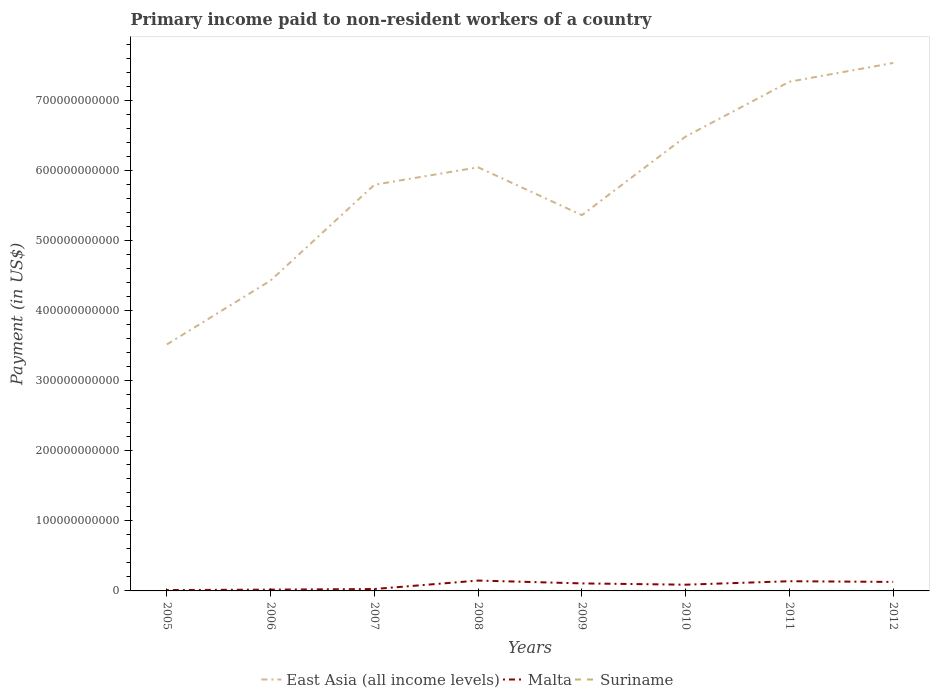How many different coloured lines are there?
Your answer should be very brief. 3. Does the line corresponding to Malta intersect with the line corresponding to East Asia (all income levels)?
Provide a succinct answer. No. Across all years, what is the maximum amount paid to workers in Malta?
Your answer should be very brief. 1.21e+09. In which year was the amount paid to workers in Suriname maximum?
Make the answer very short. 2011. What is the total amount paid to workers in Malta in the graph?
Provide a short and direct response. -1.20e+1. What is the difference between the highest and the second highest amount paid to workers in Malta?
Provide a short and direct response. 1.36e+1. What is the difference between the highest and the lowest amount paid to workers in Malta?
Ensure brevity in your answer.  5. How many years are there in the graph?
Offer a terse response. 8. What is the difference between two consecutive major ticks on the Y-axis?
Your response must be concise. 1.00e+11. Does the graph contain grids?
Ensure brevity in your answer.  No. What is the title of the graph?
Keep it short and to the point. Primary income paid to non-resident workers of a country. Does "Mali" appear as one of the legend labels in the graph?
Give a very brief answer. No. What is the label or title of the Y-axis?
Make the answer very short. Payment (in US$). What is the Payment (in US$) of East Asia (all income levels) in 2005?
Make the answer very short. 3.52e+11. What is the Payment (in US$) in Malta in 2005?
Provide a short and direct response. 1.21e+09. What is the Payment (in US$) of Suriname in 2005?
Your answer should be very brief. 2.40e+07. What is the Payment (in US$) of East Asia (all income levels) in 2006?
Offer a very short reply. 4.43e+11. What is the Payment (in US$) of Malta in 2006?
Your answer should be very brief. 1.84e+09. What is the Payment (in US$) in Suriname in 2006?
Give a very brief answer. 2.50e+07. What is the Payment (in US$) in East Asia (all income levels) in 2007?
Ensure brevity in your answer.  5.80e+11. What is the Payment (in US$) in Malta in 2007?
Your response must be concise. 2.71e+09. What is the Payment (in US$) in Suriname in 2007?
Ensure brevity in your answer.  4.36e+07. What is the Payment (in US$) in East Asia (all income levels) in 2008?
Offer a very short reply. 6.05e+11. What is the Payment (in US$) of Malta in 2008?
Give a very brief answer. 1.48e+1. What is the Payment (in US$) of Suriname in 2008?
Offer a very short reply. 4.22e+07. What is the Payment (in US$) in East Asia (all income levels) in 2009?
Your answer should be very brief. 5.36e+11. What is the Payment (in US$) of Malta in 2009?
Your answer should be compact. 1.07e+1. What is the Payment (in US$) of Suriname in 2009?
Make the answer very short. 2.98e+07. What is the Payment (in US$) of East Asia (all income levels) in 2010?
Ensure brevity in your answer.  6.48e+11. What is the Payment (in US$) of Malta in 2010?
Offer a very short reply. 8.90e+09. What is the Payment (in US$) in Suriname in 2010?
Keep it short and to the point. 2.61e+07. What is the Payment (in US$) of East Asia (all income levels) in 2011?
Provide a short and direct response. 7.27e+11. What is the Payment (in US$) in Malta in 2011?
Your answer should be compact. 1.38e+1. What is the Payment (in US$) in Suriname in 2011?
Keep it short and to the point. 1.62e+07. What is the Payment (in US$) in East Asia (all income levels) in 2012?
Provide a short and direct response. 7.53e+11. What is the Payment (in US$) in Malta in 2012?
Offer a very short reply. 1.29e+1. What is the Payment (in US$) in Suriname in 2012?
Your answer should be very brief. 2.71e+07. Across all years, what is the maximum Payment (in US$) of East Asia (all income levels)?
Offer a very short reply. 7.53e+11. Across all years, what is the maximum Payment (in US$) in Malta?
Offer a terse response. 1.48e+1. Across all years, what is the maximum Payment (in US$) in Suriname?
Your response must be concise. 4.36e+07. Across all years, what is the minimum Payment (in US$) of East Asia (all income levels)?
Make the answer very short. 3.52e+11. Across all years, what is the minimum Payment (in US$) in Malta?
Offer a very short reply. 1.21e+09. Across all years, what is the minimum Payment (in US$) in Suriname?
Keep it short and to the point. 1.62e+07. What is the total Payment (in US$) of East Asia (all income levels) in the graph?
Make the answer very short. 4.64e+12. What is the total Payment (in US$) in Malta in the graph?
Give a very brief answer. 6.69e+1. What is the total Payment (in US$) in Suriname in the graph?
Your answer should be compact. 2.34e+08. What is the difference between the Payment (in US$) of East Asia (all income levels) in 2005 and that in 2006?
Give a very brief answer. -9.13e+1. What is the difference between the Payment (in US$) in Malta in 2005 and that in 2006?
Your response must be concise. -6.32e+08. What is the difference between the Payment (in US$) in East Asia (all income levels) in 2005 and that in 2007?
Give a very brief answer. -2.28e+11. What is the difference between the Payment (in US$) in Malta in 2005 and that in 2007?
Keep it short and to the point. -1.50e+09. What is the difference between the Payment (in US$) in Suriname in 2005 and that in 2007?
Provide a short and direct response. -1.96e+07. What is the difference between the Payment (in US$) of East Asia (all income levels) in 2005 and that in 2008?
Provide a short and direct response. -2.53e+11. What is the difference between the Payment (in US$) in Malta in 2005 and that in 2008?
Your answer should be compact. -1.36e+1. What is the difference between the Payment (in US$) in Suriname in 2005 and that in 2008?
Offer a terse response. -1.82e+07. What is the difference between the Payment (in US$) in East Asia (all income levels) in 2005 and that in 2009?
Your answer should be very brief. -1.85e+11. What is the difference between the Payment (in US$) in Malta in 2005 and that in 2009?
Keep it short and to the point. -9.52e+09. What is the difference between the Payment (in US$) of Suriname in 2005 and that in 2009?
Provide a succinct answer. -5.80e+06. What is the difference between the Payment (in US$) of East Asia (all income levels) in 2005 and that in 2010?
Your response must be concise. -2.97e+11. What is the difference between the Payment (in US$) of Malta in 2005 and that in 2010?
Give a very brief answer. -7.69e+09. What is the difference between the Payment (in US$) in Suriname in 2005 and that in 2010?
Make the answer very short. -2.10e+06. What is the difference between the Payment (in US$) of East Asia (all income levels) in 2005 and that in 2011?
Your answer should be very brief. -3.75e+11. What is the difference between the Payment (in US$) of Malta in 2005 and that in 2011?
Ensure brevity in your answer.  -1.26e+1. What is the difference between the Payment (in US$) of Suriname in 2005 and that in 2011?
Make the answer very short. 7.83e+06. What is the difference between the Payment (in US$) of East Asia (all income levels) in 2005 and that in 2012?
Make the answer very short. -4.02e+11. What is the difference between the Payment (in US$) of Malta in 2005 and that in 2012?
Offer a terse response. -1.17e+1. What is the difference between the Payment (in US$) of Suriname in 2005 and that in 2012?
Provide a short and direct response. -3.10e+06. What is the difference between the Payment (in US$) of East Asia (all income levels) in 2006 and that in 2007?
Provide a succinct answer. -1.37e+11. What is the difference between the Payment (in US$) of Malta in 2006 and that in 2007?
Give a very brief answer. -8.71e+08. What is the difference between the Payment (in US$) of Suriname in 2006 and that in 2007?
Your answer should be compact. -1.86e+07. What is the difference between the Payment (in US$) in East Asia (all income levels) in 2006 and that in 2008?
Offer a very short reply. -1.62e+11. What is the difference between the Payment (in US$) of Malta in 2006 and that in 2008?
Offer a terse response. -1.30e+1. What is the difference between the Payment (in US$) in Suriname in 2006 and that in 2008?
Your response must be concise. -1.72e+07. What is the difference between the Payment (in US$) of East Asia (all income levels) in 2006 and that in 2009?
Your answer should be very brief. -9.33e+1. What is the difference between the Payment (in US$) in Malta in 2006 and that in 2009?
Your answer should be compact. -8.89e+09. What is the difference between the Payment (in US$) in Suriname in 2006 and that in 2009?
Ensure brevity in your answer.  -4.80e+06. What is the difference between the Payment (in US$) of East Asia (all income levels) in 2006 and that in 2010?
Offer a very short reply. -2.05e+11. What is the difference between the Payment (in US$) in Malta in 2006 and that in 2010?
Provide a succinct answer. -7.06e+09. What is the difference between the Payment (in US$) of Suriname in 2006 and that in 2010?
Offer a very short reply. -1.10e+06. What is the difference between the Payment (in US$) of East Asia (all income levels) in 2006 and that in 2011?
Provide a succinct answer. -2.84e+11. What is the difference between the Payment (in US$) of Malta in 2006 and that in 2011?
Your answer should be very brief. -1.20e+1. What is the difference between the Payment (in US$) in Suriname in 2006 and that in 2011?
Your response must be concise. 8.83e+06. What is the difference between the Payment (in US$) in East Asia (all income levels) in 2006 and that in 2012?
Provide a short and direct response. -3.10e+11. What is the difference between the Payment (in US$) of Malta in 2006 and that in 2012?
Make the answer very short. -1.10e+1. What is the difference between the Payment (in US$) in Suriname in 2006 and that in 2012?
Offer a very short reply. -2.10e+06. What is the difference between the Payment (in US$) in East Asia (all income levels) in 2007 and that in 2008?
Keep it short and to the point. -2.49e+1. What is the difference between the Payment (in US$) of Malta in 2007 and that in 2008?
Your answer should be very brief. -1.21e+1. What is the difference between the Payment (in US$) of Suriname in 2007 and that in 2008?
Your response must be concise. 1.40e+06. What is the difference between the Payment (in US$) of East Asia (all income levels) in 2007 and that in 2009?
Give a very brief answer. 4.34e+1. What is the difference between the Payment (in US$) of Malta in 2007 and that in 2009?
Make the answer very short. -8.02e+09. What is the difference between the Payment (in US$) in Suriname in 2007 and that in 2009?
Make the answer very short. 1.38e+07. What is the difference between the Payment (in US$) in East Asia (all income levels) in 2007 and that in 2010?
Give a very brief answer. -6.88e+1. What is the difference between the Payment (in US$) of Malta in 2007 and that in 2010?
Offer a very short reply. -6.18e+09. What is the difference between the Payment (in US$) of Suriname in 2007 and that in 2010?
Keep it short and to the point. 1.75e+07. What is the difference between the Payment (in US$) in East Asia (all income levels) in 2007 and that in 2011?
Offer a terse response. -1.47e+11. What is the difference between the Payment (in US$) in Malta in 2007 and that in 2011?
Your response must be concise. -1.11e+1. What is the difference between the Payment (in US$) of Suriname in 2007 and that in 2011?
Keep it short and to the point. 2.74e+07. What is the difference between the Payment (in US$) of East Asia (all income levels) in 2007 and that in 2012?
Your answer should be very brief. -1.74e+11. What is the difference between the Payment (in US$) in Malta in 2007 and that in 2012?
Provide a succinct answer. -1.01e+1. What is the difference between the Payment (in US$) in Suriname in 2007 and that in 2012?
Make the answer very short. 1.65e+07. What is the difference between the Payment (in US$) of East Asia (all income levels) in 2008 and that in 2009?
Keep it short and to the point. 6.83e+1. What is the difference between the Payment (in US$) of Malta in 2008 and that in 2009?
Make the answer very short. 4.06e+09. What is the difference between the Payment (in US$) of Suriname in 2008 and that in 2009?
Provide a short and direct response. 1.24e+07. What is the difference between the Payment (in US$) in East Asia (all income levels) in 2008 and that in 2010?
Offer a terse response. -4.39e+1. What is the difference between the Payment (in US$) in Malta in 2008 and that in 2010?
Give a very brief answer. 5.90e+09. What is the difference between the Payment (in US$) in Suriname in 2008 and that in 2010?
Keep it short and to the point. 1.61e+07. What is the difference between the Payment (in US$) of East Asia (all income levels) in 2008 and that in 2011?
Offer a terse response. -1.22e+11. What is the difference between the Payment (in US$) of Malta in 2008 and that in 2011?
Keep it short and to the point. 9.48e+08. What is the difference between the Payment (in US$) in Suriname in 2008 and that in 2011?
Provide a succinct answer. 2.60e+07. What is the difference between the Payment (in US$) of East Asia (all income levels) in 2008 and that in 2012?
Your answer should be very brief. -1.49e+11. What is the difference between the Payment (in US$) in Malta in 2008 and that in 2012?
Your response must be concise. 1.93e+09. What is the difference between the Payment (in US$) in Suriname in 2008 and that in 2012?
Provide a short and direct response. 1.51e+07. What is the difference between the Payment (in US$) in East Asia (all income levels) in 2009 and that in 2010?
Your answer should be compact. -1.12e+11. What is the difference between the Payment (in US$) in Malta in 2009 and that in 2010?
Offer a terse response. 1.84e+09. What is the difference between the Payment (in US$) in Suriname in 2009 and that in 2010?
Give a very brief answer. 3.70e+06. What is the difference between the Payment (in US$) of East Asia (all income levels) in 2009 and that in 2011?
Offer a terse response. -1.90e+11. What is the difference between the Payment (in US$) in Malta in 2009 and that in 2011?
Ensure brevity in your answer.  -3.11e+09. What is the difference between the Payment (in US$) in Suriname in 2009 and that in 2011?
Your response must be concise. 1.36e+07. What is the difference between the Payment (in US$) in East Asia (all income levels) in 2009 and that in 2012?
Give a very brief answer. -2.17e+11. What is the difference between the Payment (in US$) in Malta in 2009 and that in 2012?
Your answer should be compact. -2.13e+09. What is the difference between the Payment (in US$) of Suriname in 2009 and that in 2012?
Provide a succinct answer. 2.70e+06. What is the difference between the Payment (in US$) of East Asia (all income levels) in 2010 and that in 2011?
Ensure brevity in your answer.  -7.82e+1. What is the difference between the Payment (in US$) in Malta in 2010 and that in 2011?
Your answer should be compact. -4.95e+09. What is the difference between the Payment (in US$) in Suriname in 2010 and that in 2011?
Your answer should be compact. 9.93e+06. What is the difference between the Payment (in US$) of East Asia (all income levels) in 2010 and that in 2012?
Your answer should be very brief. -1.05e+11. What is the difference between the Payment (in US$) in Malta in 2010 and that in 2012?
Ensure brevity in your answer.  -3.97e+09. What is the difference between the Payment (in US$) of Suriname in 2010 and that in 2012?
Provide a short and direct response. -1.00e+06. What is the difference between the Payment (in US$) in East Asia (all income levels) in 2011 and that in 2012?
Your answer should be very brief. -2.68e+1. What is the difference between the Payment (in US$) in Malta in 2011 and that in 2012?
Give a very brief answer. 9.84e+08. What is the difference between the Payment (in US$) in Suriname in 2011 and that in 2012?
Provide a short and direct response. -1.09e+07. What is the difference between the Payment (in US$) in East Asia (all income levels) in 2005 and the Payment (in US$) in Malta in 2006?
Provide a short and direct response. 3.50e+11. What is the difference between the Payment (in US$) of East Asia (all income levels) in 2005 and the Payment (in US$) of Suriname in 2006?
Your response must be concise. 3.52e+11. What is the difference between the Payment (in US$) in Malta in 2005 and the Payment (in US$) in Suriname in 2006?
Provide a short and direct response. 1.18e+09. What is the difference between the Payment (in US$) in East Asia (all income levels) in 2005 and the Payment (in US$) in Malta in 2007?
Your response must be concise. 3.49e+11. What is the difference between the Payment (in US$) of East Asia (all income levels) in 2005 and the Payment (in US$) of Suriname in 2007?
Make the answer very short. 3.52e+11. What is the difference between the Payment (in US$) in Malta in 2005 and the Payment (in US$) in Suriname in 2007?
Keep it short and to the point. 1.16e+09. What is the difference between the Payment (in US$) of East Asia (all income levels) in 2005 and the Payment (in US$) of Malta in 2008?
Offer a terse response. 3.37e+11. What is the difference between the Payment (in US$) in East Asia (all income levels) in 2005 and the Payment (in US$) in Suriname in 2008?
Give a very brief answer. 3.52e+11. What is the difference between the Payment (in US$) of Malta in 2005 and the Payment (in US$) of Suriname in 2008?
Your response must be concise. 1.17e+09. What is the difference between the Payment (in US$) of East Asia (all income levels) in 2005 and the Payment (in US$) of Malta in 2009?
Your answer should be very brief. 3.41e+11. What is the difference between the Payment (in US$) of East Asia (all income levels) in 2005 and the Payment (in US$) of Suriname in 2009?
Offer a terse response. 3.52e+11. What is the difference between the Payment (in US$) of Malta in 2005 and the Payment (in US$) of Suriname in 2009?
Your answer should be compact. 1.18e+09. What is the difference between the Payment (in US$) of East Asia (all income levels) in 2005 and the Payment (in US$) of Malta in 2010?
Your answer should be compact. 3.43e+11. What is the difference between the Payment (in US$) of East Asia (all income levels) in 2005 and the Payment (in US$) of Suriname in 2010?
Offer a terse response. 3.52e+11. What is the difference between the Payment (in US$) in Malta in 2005 and the Payment (in US$) in Suriname in 2010?
Provide a succinct answer. 1.18e+09. What is the difference between the Payment (in US$) in East Asia (all income levels) in 2005 and the Payment (in US$) in Malta in 2011?
Provide a succinct answer. 3.38e+11. What is the difference between the Payment (in US$) in East Asia (all income levels) in 2005 and the Payment (in US$) in Suriname in 2011?
Your answer should be compact. 3.52e+11. What is the difference between the Payment (in US$) of Malta in 2005 and the Payment (in US$) of Suriname in 2011?
Keep it short and to the point. 1.19e+09. What is the difference between the Payment (in US$) of East Asia (all income levels) in 2005 and the Payment (in US$) of Malta in 2012?
Give a very brief answer. 3.39e+11. What is the difference between the Payment (in US$) of East Asia (all income levels) in 2005 and the Payment (in US$) of Suriname in 2012?
Your answer should be compact. 3.52e+11. What is the difference between the Payment (in US$) in Malta in 2005 and the Payment (in US$) in Suriname in 2012?
Your answer should be very brief. 1.18e+09. What is the difference between the Payment (in US$) of East Asia (all income levels) in 2006 and the Payment (in US$) of Malta in 2007?
Make the answer very short. 4.40e+11. What is the difference between the Payment (in US$) of East Asia (all income levels) in 2006 and the Payment (in US$) of Suriname in 2007?
Offer a terse response. 4.43e+11. What is the difference between the Payment (in US$) in Malta in 2006 and the Payment (in US$) in Suriname in 2007?
Offer a very short reply. 1.80e+09. What is the difference between the Payment (in US$) in East Asia (all income levels) in 2006 and the Payment (in US$) in Malta in 2008?
Give a very brief answer. 4.28e+11. What is the difference between the Payment (in US$) in East Asia (all income levels) in 2006 and the Payment (in US$) in Suriname in 2008?
Provide a succinct answer. 4.43e+11. What is the difference between the Payment (in US$) in Malta in 2006 and the Payment (in US$) in Suriname in 2008?
Provide a short and direct response. 1.80e+09. What is the difference between the Payment (in US$) of East Asia (all income levels) in 2006 and the Payment (in US$) of Malta in 2009?
Offer a terse response. 4.32e+11. What is the difference between the Payment (in US$) of East Asia (all income levels) in 2006 and the Payment (in US$) of Suriname in 2009?
Provide a short and direct response. 4.43e+11. What is the difference between the Payment (in US$) in Malta in 2006 and the Payment (in US$) in Suriname in 2009?
Give a very brief answer. 1.81e+09. What is the difference between the Payment (in US$) in East Asia (all income levels) in 2006 and the Payment (in US$) in Malta in 2010?
Ensure brevity in your answer.  4.34e+11. What is the difference between the Payment (in US$) of East Asia (all income levels) in 2006 and the Payment (in US$) of Suriname in 2010?
Your answer should be very brief. 4.43e+11. What is the difference between the Payment (in US$) in Malta in 2006 and the Payment (in US$) in Suriname in 2010?
Ensure brevity in your answer.  1.81e+09. What is the difference between the Payment (in US$) in East Asia (all income levels) in 2006 and the Payment (in US$) in Malta in 2011?
Ensure brevity in your answer.  4.29e+11. What is the difference between the Payment (in US$) of East Asia (all income levels) in 2006 and the Payment (in US$) of Suriname in 2011?
Your answer should be very brief. 4.43e+11. What is the difference between the Payment (in US$) of Malta in 2006 and the Payment (in US$) of Suriname in 2011?
Offer a very short reply. 1.82e+09. What is the difference between the Payment (in US$) of East Asia (all income levels) in 2006 and the Payment (in US$) of Malta in 2012?
Your response must be concise. 4.30e+11. What is the difference between the Payment (in US$) in East Asia (all income levels) in 2006 and the Payment (in US$) in Suriname in 2012?
Ensure brevity in your answer.  4.43e+11. What is the difference between the Payment (in US$) in Malta in 2006 and the Payment (in US$) in Suriname in 2012?
Give a very brief answer. 1.81e+09. What is the difference between the Payment (in US$) of East Asia (all income levels) in 2007 and the Payment (in US$) of Malta in 2008?
Your answer should be very brief. 5.65e+11. What is the difference between the Payment (in US$) in East Asia (all income levels) in 2007 and the Payment (in US$) in Suriname in 2008?
Provide a succinct answer. 5.80e+11. What is the difference between the Payment (in US$) in Malta in 2007 and the Payment (in US$) in Suriname in 2008?
Ensure brevity in your answer.  2.67e+09. What is the difference between the Payment (in US$) in East Asia (all income levels) in 2007 and the Payment (in US$) in Malta in 2009?
Offer a terse response. 5.69e+11. What is the difference between the Payment (in US$) in East Asia (all income levels) in 2007 and the Payment (in US$) in Suriname in 2009?
Your answer should be very brief. 5.80e+11. What is the difference between the Payment (in US$) of Malta in 2007 and the Payment (in US$) of Suriname in 2009?
Keep it short and to the point. 2.68e+09. What is the difference between the Payment (in US$) of East Asia (all income levels) in 2007 and the Payment (in US$) of Malta in 2010?
Give a very brief answer. 5.71e+11. What is the difference between the Payment (in US$) of East Asia (all income levels) in 2007 and the Payment (in US$) of Suriname in 2010?
Your answer should be very brief. 5.80e+11. What is the difference between the Payment (in US$) of Malta in 2007 and the Payment (in US$) of Suriname in 2010?
Offer a terse response. 2.68e+09. What is the difference between the Payment (in US$) of East Asia (all income levels) in 2007 and the Payment (in US$) of Malta in 2011?
Offer a very short reply. 5.66e+11. What is the difference between the Payment (in US$) of East Asia (all income levels) in 2007 and the Payment (in US$) of Suriname in 2011?
Keep it short and to the point. 5.80e+11. What is the difference between the Payment (in US$) of Malta in 2007 and the Payment (in US$) of Suriname in 2011?
Ensure brevity in your answer.  2.69e+09. What is the difference between the Payment (in US$) in East Asia (all income levels) in 2007 and the Payment (in US$) in Malta in 2012?
Offer a very short reply. 5.67e+11. What is the difference between the Payment (in US$) of East Asia (all income levels) in 2007 and the Payment (in US$) of Suriname in 2012?
Make the answer very short. 5.80e+11. What is the difference between the Payment (in US$) in Malta in 2007 and the Payment (in US$) in Suriname in 2012?
Your answer should be compact. 2.68e+09. What is the difference between the Payment (in US$) in East Asia (all income levels) in 2008 and the Payment (in US$) in Malta in 2009?
Your answer should be very brief. 5.94e+11. What is the difference between the Payment (in US$) in East Asia (all income levels) in 2008 and the Payment (in US$) in Suriname in 2009?
Provide a short and direct response. 6.04e+11. What is the difference between the Payment (in US$) in Malta in 2008 and the Payment (in US$) in Suriname in 2009?
Your answer should be very brief. 1.48e+1. What is the difference between the Payment (in US$) in East Asia (all income levels) in 2008 and the Payment (in US$) in Malta in 2010?
Your answer should be very brief. 5.96e+11. What is the difference between the Payment (in US$) in East Asia (all income levels) in 2008 and the Payment (in US$) in Suriname in 2010?
Give a very brief answer. 6.04e+11. What is the difference between the Payment (in US$) in Malta in 2008 and the Payment (in US$) in Suriname in 2010?
Your answer should be very brief. 1.48e+1. What is the difference between the Payment (in US$) in East Asia (all income levels) in 2008 and the Payment (in US$) in Malta in 2011?
Provide a short and direct response. 5.91e+11. What is the difference between the Payment (in US$) in East Asia (all income levels) in 2008 and the Payment (in US$) in Suriname in 2011?
Offer a terse response. 6.04e+11. What is the difference between the Payment (in US$) in Malta in 2008 and the Payment (in US$) in Suriname in 2011?
Ensure brevity in your answer.  1.48e+1. What is the difference between the Payment (in US$) in East Asia (all income levels) in 2008 and the Payment (in US$) in Malta in 2012?
Keep it short and to the point. 5.92e+11. What is the difference between the Payment (in US$) in East Asia (all income levels) in 2008 and the Payment (in US$) in Suriname in 2012?
Offer a very short reply. 6.04e+11. What is the difference between the Payment (in US$) of Malta in 2008 and the Payment (in US$) of Suriname in 2012?
Your answer should be very brief. 1.48e+1. What is the difference between the Payment (in US$) of East Asia (all income levels) in 2009 and the Payment (in US$) of Malta in 2010?
Your answer should be very brief. 5.27e+11. What is the difference between the Payment (in US$) in East Asia (all income levels) in 2009 and the Payment (in US$) in Suriname in 2010?
Offer a terse response. 5.36e+11. What is the difference between the Payment (in US$) of Malta in 2009 and the Payment (in US$) of Suriname in 2010?
Your answer should be compact. 1.07e+1. What is the difference between the Payment (in US$) in East Asia (all income levels) in 2009 and the Payment (in US$) in Malta in 2011?
Your answer should be compact. 5.22e+11. What is the difference between the Payment (in US$) in East Asia (all income levels) in 2009 and the Payment (in US$) in Suriname in 2011?
Your response must be concise. 5.36e+11. What is the difference between the Payment (in US$) of Malta in 2009 and the Payment (in US$) of Suriname in 2011?
Make the answer very short. 1.07e+1. What is the difference between the Payment (in US$) of East Asia (all income levels) in 2009 and the Payment (in US$) of Malta in 2012?
Give a very brief answer. 5.23e+11. What is the difference between the Payment (in US$) in East Asia (all income levels) in 2009 and the Payment (in US$) in Suriname in 2012?
Your answer should be compact. 5.36e+11. What is the difference between the Payment (in US$) in Malta in 2009 and the Payment (in US$) in Suriname in 2012?
Provide a short and direct response. 1.07e+1. What is the difference between the Payment (in US$) in East Asia (all income levels) in 2010 and the Payment (in US$) in Malta in 2011?
Keep it short and to the point. 6.35e+11. What is the difference between the Payment (in US$) in East Asia (all income levels) in 2010 and the Payment (in US$) in Suriname in 2011?
Offer a terse response. 6.48e+11. What is the difference between the Payment (in US$) of Malta in 2010 and the Payment (in US$) of Suriname in 2011?
Offer a very short reply. 8.88e+09. What is the difference between the Payment (in US$) of East Asia (all income levels) in 2010 and the Payment (in US$) of Malta in 2012?
Your answer should be compact. 6.36e+11. What is the difference between the Payment (in US$) of East Asia (all income levels) in 2010 and the Payment (in US$) of Suriname in 2012?
Provide a succinct answer. 6.48e+11. What is the difference between the Payment (in US$) in Malta in 2010 and the Payment (in US$) in Suriname in 2012?
Make the answer very short. 8.87e+09. What is the difference between the Payment (in US$) of East Asia (all income levels) in 2011 and the Payment (in US$) of Malta in 2012?
Give a very brief answer. 7.14e+11. What is the difference between the Payment (in US$) of East Asia (all income levels) in 2011 and the Payment (in US$) of Suriname in 2012?
Provide a succinct answer. 7.27e+11. What is the difference between the Payment (in US$) of Malta in 2011 and the Payment (in US$) of Suriname in 2012?
Offer a very short reply. 1.38e+1. What is the average Payment (in US$) of East Asia (all income levels) per year?
Your response must be concise. 5.80e+11. What is the average Payment (in US$) in Malta per year?
Your answer should be compact. 8.36e+09. What is the average Payment (in US$) of Suriname per year?
Provide a succinct answer. 2.92e+07. In the year 2005, what is the difference between the Payment (in US$) in East Asia (all income levels) and Payment (in US$) in Malta?
Give a very brief answer. 3.50e+11. In the year 2005, what is the difference between the Payment (in US$) in East Asia (all income levels) and Payment (in US$) in Suriname?
Your response must be concise. 3.52e+11. In the year 2005, what is the difference between the Payment (in US$) in Malta and Payment (in US$) in Suriname?
Your answer should be very brief. 1.18e+09. In the year 2006, what is the difference between the Payment (in US$) in East Asia (all income levels) and Payment (in US$) in Malta?
Your answer should be very brief. 4.41e+11. In the year 2006, what is the difference between the Payment (in US$) of East Asia (all income levels) and Payment (in US$) of Suriname?
Offer a very short reply. 4.43e+11. In the year 2006, what is the difference between the Payment (in US$) of Malta and Payment (in US$) of Suriname?
Give a very brief answer. 1.81e+09. In the year 2007, what is the difference between the Payment (in US$) in East Asia (all income levels) and Payment (in US$) in Malta?
Your answer should be very brief. 5.77e+11. In the year 2007, what is the difference between the Payment (in US$) in East Asia (all income levels) and Payment (in US$) in Suriname?
Your answer should be very brief. 5.80e+11. In the year 2007, what is the difference between the Payment (in US$) of Malta and Payment (in US$) of Suriname?
Offer a terse response. 2.67e+09. In the year 2008, what is the difference between the Payment (in US$) of East Asia (all income levels) and Payment (in US$) of Malta?
Offer a terse response. 5.90e+11. In the year 2008, what is the difference between the Payment (in US$) in East Asia (all income levels) and Payment (in US$) in Suriname?
Your response must be concise. 6.04e+11. In the year 2008, what is the difference between the Payment (in US$) of Malta and Payment (in US$) of Suriname?
Make the answer very short. 1.48e+1. In the year 2009, what is the difference between the Payment (in US$) in East Asia (all income levels) and Payment (in US$) in Malta?
Offer a very short reply. 5.26e+11. In the year 2009, what is the difference between the Payment (in US$) of East Asia (all income levels) and Payment (in US$) of Suriname?
Offer a terse response. 5.36e+11. In the year 2009, what is the difference between the Payment (in US$) of Malta and Payment (in US$) of Suriname?
Give a very brief answer. 1.07e+1. In the year 2010, what is the difference between the Payment (in US$) in East Asia (all income levels) and Payment (in US$) in Malta?
Your response must be concise. 6.40e+11. In the year 2010, what is the difference between the Payment (in US$) of East Asia (all income levels) and Payment (in US$) of Suriname?
Make the answer very short. 6.48e+11. In the year 2010, what is the difference between the Payment (in US$) in Malta and Payment (in US$) in Suriname?
Offer a terse response. 8.87e+09. In the year 2011, what is the difference between the Payment (in US$) in East Asia (all income levels) and Payment (in US$) in Malta?
Provide a succinct answer. 7.13e+11. In the year 2011, what is the difference between the Payment (in US$) of East Asia (all income levels) and Payment (in US$) of Suriname?
Provide a short and direct response. 7.27e+11. In the year 2011, what is the difference between the Payment (in US$) in Malta and Payment (in US$) in Suriname?
Provide a succinct answer. 1.38e+1. In the year 2012, what is the difference between the Payment (in US$) in East Asia (all income levels) and Payment (in US$) in Malta?
Keep it short and to the point. 7.41e+11. In the year 2012, what is the difference between the Payment (in US$) in East Asia (all income levels) and Payment (in US$) in Suriname?
Your response must be concise. 7.53e+11. In the year 2012, what is the difference between the Payment (in US$) of Malta and Payment (in US$) of Suriname?
Keep it short and to the point. 1.28e+1. What is the ratio of the Payment (in US$) in East Asia (all income levels) in 2005 to that in 2006?
Offer a very short reply. 0.79. What is the ratio of the Payment (in US$) of Malta in 2005 to that in 2006?
Provide a succinct answer. 0.66. What is the ratio of the Payment (in US$) in Suriname in 2005 to that in 2006?
Offer a terse response. 0.96. What is the ratio of the Payment (in US$) of East Asia (all income levels) in 2005 to that in 2007?
Offer a terse response. 0.61. What is the ratio of the Payment (in US$) of Malta in 2005 to that in 2007?
Your answer should be very brief. 0.45. What is the ratio of the Payment (in US$) in Suriname in 2005 to that in 2007?
Ensure brevity in your answer.  0.55. What is the ratio of the Payment (in US$) in East Asia (all income levels) in 2005 to that in 2008?
Give a very brief answer. 0.58. What is the ratio of the Payment (in US$) in Malta in 2005 to that in 2008?
Ensure brevity in your answer.  0.08. What is the ratio of the Payment (in US$) in Suriname in 2005 to that in 2008?
Your response must be concise. 0.57. What is the ratio of the Payment (in US$) of East Asia (all income levels) in 2005 to that in 2009?
Provide a short and direct response. 0.66. What is the ratio of the Payment (in US$) in Malta in 2005 to that in 2009?
Your answer should be very brief. 0.11. What is the ratio of the Payment (in US$) in Suriname in 2005 to that in 2009?
Offer a terse response. 0.81. What is the ratio of the Payment (in US$) of East Asia (all income levels) in 2005 to that in 2010?
Provide a succinct answer. 0.54. What is the ratio of the Payment (in US$) in Malta in 2005 to that in 2010?
Give a very brief answer. 0.14. What is the ratio of the Payment (in US$) of Suriname in 2005 to that in 2010?
Keep it short and to the point. 0.92. What is the ratio of the Payment (in US$) in East Asia (all income levels) in 2005 to that in 2011?
Offer a very short reply. 0.48. What is the ratio of the Payment (in US$) in Malta in 2005 to that in 2011?
Provide a short and direct response. 0.09. What is the ratio of the Payment (in US$) in Suriname in 2005 to that in 2011?
Your response must be concise. 1.48. What is the ratio of the Payment (in US$) of East Asia (all income levels) in 2005 to that in 2012?
Provide a succinct answer. 0.47. What is the ratio of the Payment (in US$) of Malta in 2005 to that in 2012?
Offer a very short reply. 0.09. What is the ratio of the Payment (in US$) of Suriname in 2005 to that in 2012?
Your response must be concise. 0.89. What is the ratio of the Payment (in US$) in East Asia (all income levels) in 2006 to that in 2007?
Provide a short and direct response. 0.76. What is the ratio of the Payment (in US$) of Malta in 2006 to that in 2007?
Provide a short and direct response. 0.68. What is the ratio of the Payment (in US$) of Suriname in 2006 to that in 2007?
Keep it short and to the point. 0.57. What is the ratio of the Payment (in US$) of East Asia (all income levels) in 2006 to that in 2008?
Offer a very short reply. 0.73. What is the ratio of the Payment (in US$) of Malta in 2006 to that in 2008?
Ensure brevity in your answer.  0.12. What is the ratio of the Payment (in US$) of Suriname in 2006 to that in 2008?
Make the answer very short. 0.59. What is the ratio of the Payment (in US$) of East Asia (all income levels) in 2006 to that in 2009?
Make the answer very short. 0.83. What is the ratio of the Payment (in US$) in Malta in 2006 to that in 2009?
Keep it short and to the point. 0.17. What is the ratio of the Payment (in US$) of Suriname in 2006 to that in 2009?
Provide a short and direct response. 0.84. What is the ratio of the Payment (in US$) in East Asia (all income levels) in 2006 to that in 2010?
Ensure brevity in your answer.  0.68. What is the ratio of the Payment (in US$) of Malta in 2006 to that in 2010?
Your answer should be very brief. 0.21. What is the ratio of the Payment (in US$) in Suriname in 2006 to that in 2010?
Provide a succinct answer. 0.96. What is the ratio of the Payment (in US$) of East Asia (all income levels) in 2006 to that in 2011?
Offer a terse response. 0.61. What is the ratio of the Payment (in US$) in Malta in 2006 to that in 2011?
Ensure brevity in your answer.  0.13. What is the ratio of the Payment (in US$) in Suriname in 2006 to that in 2011?
Ensure brevity in your answer.  1.55. What is the ratio of the Payment (in US$) in East Asia (all income levels) in 2006 to that in 2012?
Make the answer very short. 0.59. What is the ratio of the Payment (in US$) of Malta in 2006 to that in 2012?
Provide a succinct answer. 0.14. What is the ratio of the Payment (in US$) in Suriname in 2006 to that in 2012?
Give a very brief answer. 0.92. What is the ratio of the Payment (in US$) in East Asia (all income levels) in 2007 to that in 2008?
Make the answer very short. 0.96. What is the ratio of the Payment (in US$) of Malta in 2007 to that in 2008?
Make the answer very short. 0.18. What is the ratio of the Payment (in US$) of Suriname in 2007 to that in 2008?
Your answer should be very brief. 1.03. What is the ratio of the Payment (in US$) in East Asia (all income levels) in 2007 to that in 2009?
Your answer should be compact. 1.08. What is the ratio of the Payment (in US$) in Malta in 2007 to that in 2009?
Give a very brief answer. 0.25. What is the ratio of the Payment (in US$) of Suriname in 2007 to that in 2009?
Your answer should be compact. 1.46. What is the ratio of the Payment (in US$) of East Asia (all income levels) in 2007 to that in 2010?
Ensure brevity in your answer.  0.89. What is the ratio of the Payment (in US$) in Malta in 2007 to that in 2010?
Ensure brevity in your answer.  0.3. What is the ratio of the Payment (in US$) of Suriname in 2007 to that in 2010?
Your answer should be compact. 1.67. What is the ratio of the Payment (in US$) of East Asia (all income levels) in 2007 to that in 2011?
Make the answer very short. 0.8. What is the ratio of the Payment (in US$) in Malta in 2007 to that in 2011?
Make the answer very short. 0.2. What is the ratio of the Payment (in US$) in Suriname in 2007 to that in 2011?
Offer a terse response. 2.7. What is the ratio of the Payment (in US$) of East Asia (all income levels) in 2007 to that in 2012?
Your answer should be compact. 0.77. What is the ratio of the Payment (in US$) of Malta in 2007 to that in 2012?
Your response must be concise. 0.21. What is the ratio of the Payment (in US$) in Suriname in 2007 to that in 2012?
Your response must be concise. 1.61. What is the ratio of the Payment (in US$) of East Asia (all income levels) in 2008 to that in 2009?
Provide a succinct answer. 1.13. What is the ratio of the Payment (in US$) in Malta in 2008 to that in 2009?
Provide a short and direct response. 1.38. What is the ratio of the Payment (in US$) in Suriname in 2008 to that in 2009?
Give a very brief answer. 1.42. What is the ratio of the Payment (in US$) in East Asia (all income levels) in 2008 to that in 2010?
Make the answer very short. 0.93. What is the ratio of the Payment (in US$) in Malta in 2008 to that in 2010?
Provide a short and direct response. 1.66. What is the ratio of the Payment (in US$) of Suriname in 2008 to that in 2010?
Keep it short and to the point. 1.62. What is the ratio of the Payment (in US$) in East Asia (all income levels) in 2008 to that in 2011?
Make the answer very short. 0.83. What is the ratio of the Payment (in US$) of Malta in 2008 to that in 2011?
Offer a very short reply. 1.07. What is the ratio of the Payment (in US$) of Suriname in 2008 to that in 2011?
Make the answer very short. 2.61. What is the ratio of the Payment (in US$) of East Asia (all income levels) in 2008 to that in 2012?
Ensure brevity in your answer.  0.8. What is the ratio of the Payment (in US$) in Malta in 2008 to that in 2012?
Provide a short and direct response. 1.15. What is the ratio of the Payment (in US$) of Suriname in 2008 to that in 2012?
Provide a short and direct response. 1.56. What is the ratio of the Payment (in US$) in East Asia (all income levels) in 2009 to that in 2010?
Make the answer very short. 0.83. What is the ratio of the Payment (in US$) of Malta in 2009 to that in 2010?
Your answer should be compact. 1.21. What is the ratio of the Payment (in US$) of Suriname in 2009 to that in 2010?
Keep it short and to the point. 1.14. What is the ratio of the Payment (in US$) in East Asia (all income levels) in 2009 to that in 2011?
Your answer should be very brief. 0.74. What is the ratio of the Payment (in US$) in Malta in 2009 to that in 2011?
Your response must be concise. 0.78. What is the ratio of the Payment (in US$) of Suriname in 2009 to that in 2011?
Make the answer very short. 1.84. What is the ratio of the Payment (in US$) of East Asia (all income levels) in 2009 to that in 2012?
Provide a succinct answer. 0.71. What is the ratio of the Payment (in US$) in Malta in 2009 to that in 2012?
Your answer should be compact. 0.83. What is the ratio of the Payment (in US$) of Suriname in 2009 to that in 2012?
Your answer should be compact. 1.1. What is the ratio of the Payment (in US$) of East Asia (all income levels) in 2010 to that in 2011?
Make the answer very short. 0.89. What is the ratio of the Payment (in US$) in Malta in 2010 to that in 2011?
Keep it short and to the point. 0.64. What is the ratio of the Payment (in US$) of Suriname in 2010 to that in 2011?
Your response must be concise. 1.61. What is the ratio of the Payment (in US$) of East Asia (all income levels) in 2010 to that in 2012?
Keep it short and to the point. 0.86. What is the ratio of the Payment (in US$) of Malta in 2010 to that in 2012?
Offer a terse response. 0.69. What is the ratio of the Payment (in US$) of Suriname in 2010 to that in 2012?
Your answer should be very brief. 0.96. What is the ratio of the Payment (in US$) in East Asia (all income levels) in 2011 to that in 2012?
Your answer should be very brief. 0.96. What is the ratio of the Payment (in US$) in Malta in 2011 to that in 2012?
Give a very brief answer. 1.08. What is the ratio of the Payment (in US$) in Suriname in 2011 to that in 2012?
Your answer should be compact. 0.6. What is the difference between the highest and the second highest Payment (in US$) of East Asia (all income levels)?
Provide a succinct answer. 2.68e+1. What is the difference between the highest and the second highest Payment (in US$) of Malta?
Offer a very short reply. 9.48e+08. What is the difference between the highest and the second highest Payment (in US$) in Suriname?
Provide a succinct answer. 1.40e+06. What is the difference between the highest and the lowest Payment (in US$) in East Asia (all income levels)?
Make the answer very short. 4.02e+11. What is the difference between the highest and the lowest Payment (in US$) in Malta?
Provide a succinct answer. 1.36e+1. What is the difference between the highest and the lowest Payment (in US$) of Suriname?
Your answer should be very brief. 2.74e+07. 